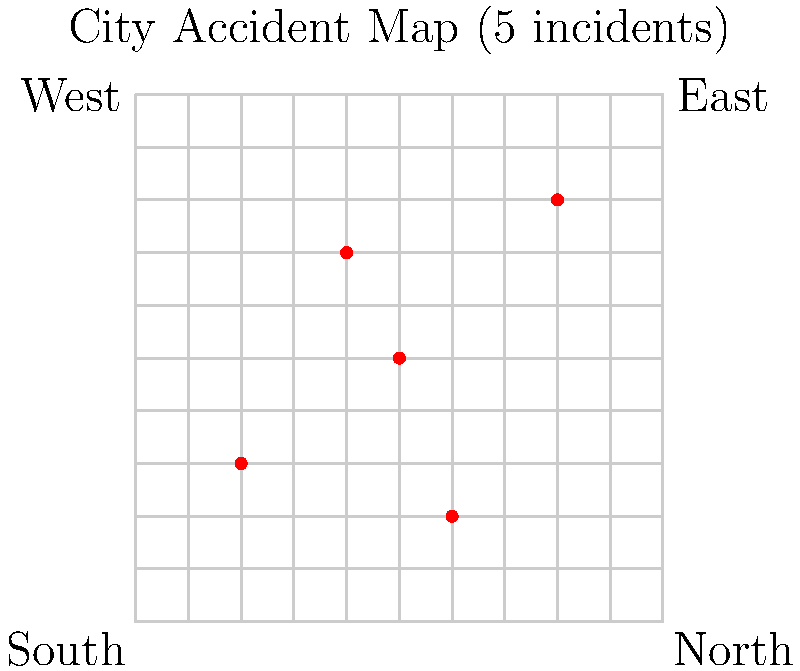Based on the city map showing accident locations, what percentage of the total grid area can be considered "accident-free" if we assume each incident affects a 1x1 unit area around it? To solve this problem, let's follow these steps:

1. Calculate the total area of the grid:
   Total area = $10 \times 10 = 100$ square units

2. Count the number of accident locations:
   There are 5 accident locations marked on the map.

3. Calculate the affected area for each accident:
   Each accident affects a 1x1 unit area around it, so each incident covers 1 square unit.

4. Calculate the total affected area:
   Total affected area = $5 \times 1 = 5$ square units

5. Calculate the "accident-free" area:
   Accident-free area = Total area - Total affected area
   $= 100 - 5 = 95$ square units

6. Calculate the percentage of "accident-free" area:
   Percentage = (Accident-free area / Total area) $\times 100\%$
   $= (95 / 100) \times 100\% = 95\%$

Therefore, 95% of the total grid area can be considered "accident-free".
Answer: 95% 